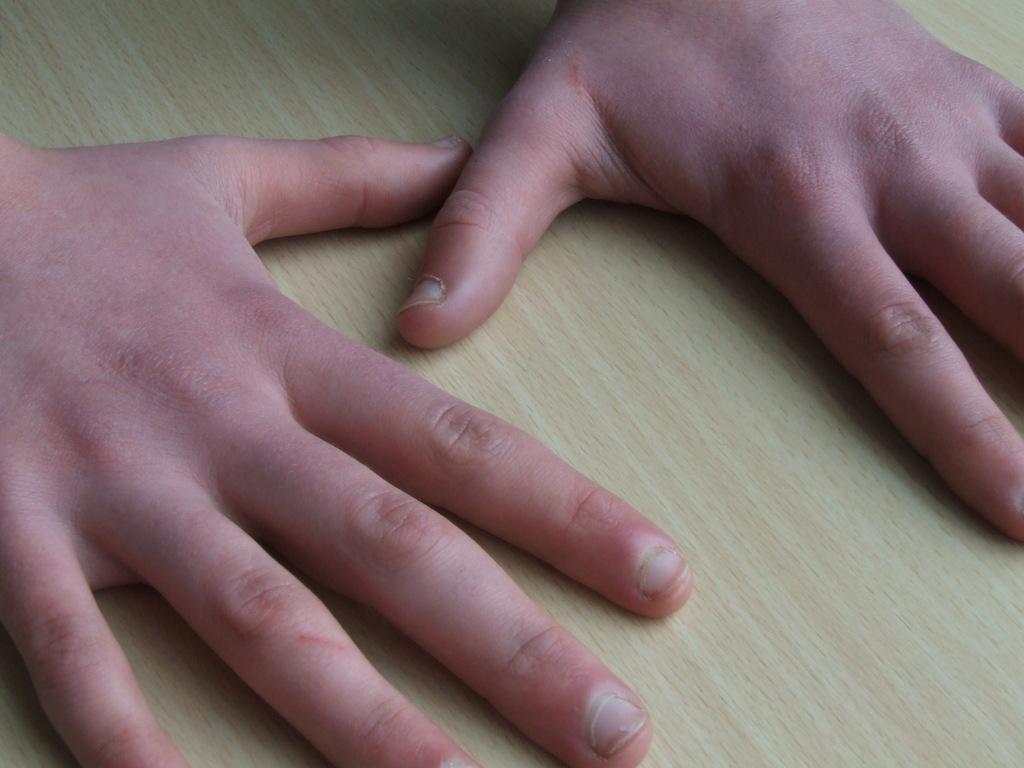In one or two sentences, can you explain what this image depicts? In this picture we can see a close view on the boys hands on the wooden table top. 